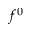<formula> <loc_0><loc_0><loc_500><loc_500>f ^ { 0 }</formula> 